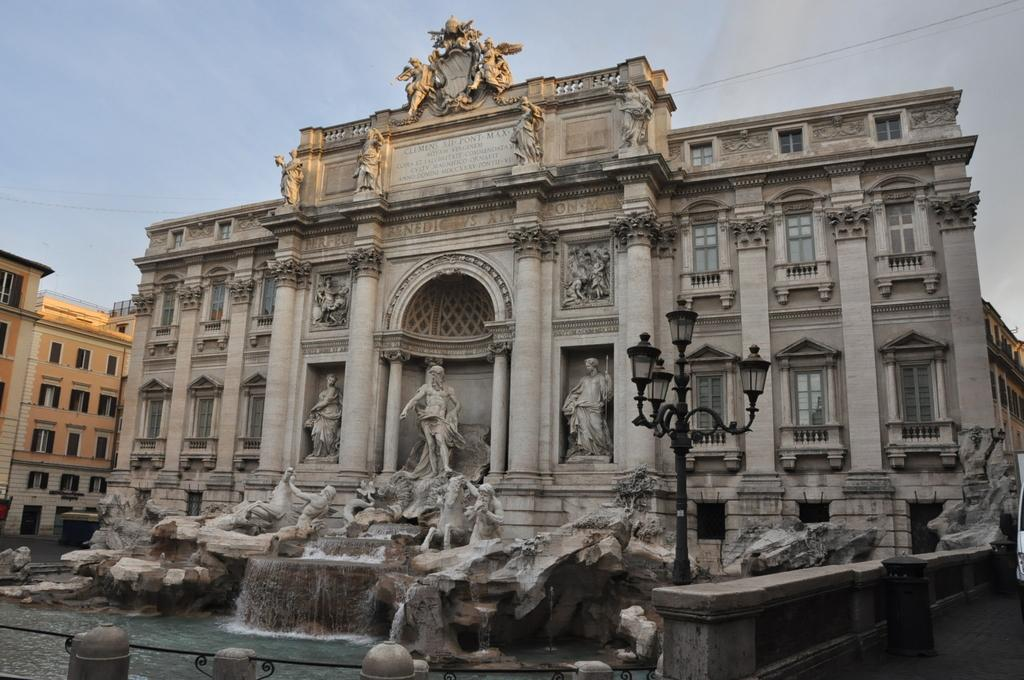What type of structures can be seen in the image? There are buildings in the image. Are there any decorative elements on the buildings? Yes, some sculptures are present on the buildings. What type of lighting is visible in the image? Street lights are visible in the image. What natural element is present in the image? There is water in the image. What can be seen in the background of the image? The sky is visible in the background of the image. How many chairs are placed around the clam in the image? There is no clam or chairs present in the image. What type of hose is connected to the water in the image? There is no hose present in the image; it only shows water. 